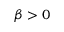Convert formula to latex. <formula><loc_0><loc_0><loc_500><loc_500>\beta > 0</formula> 